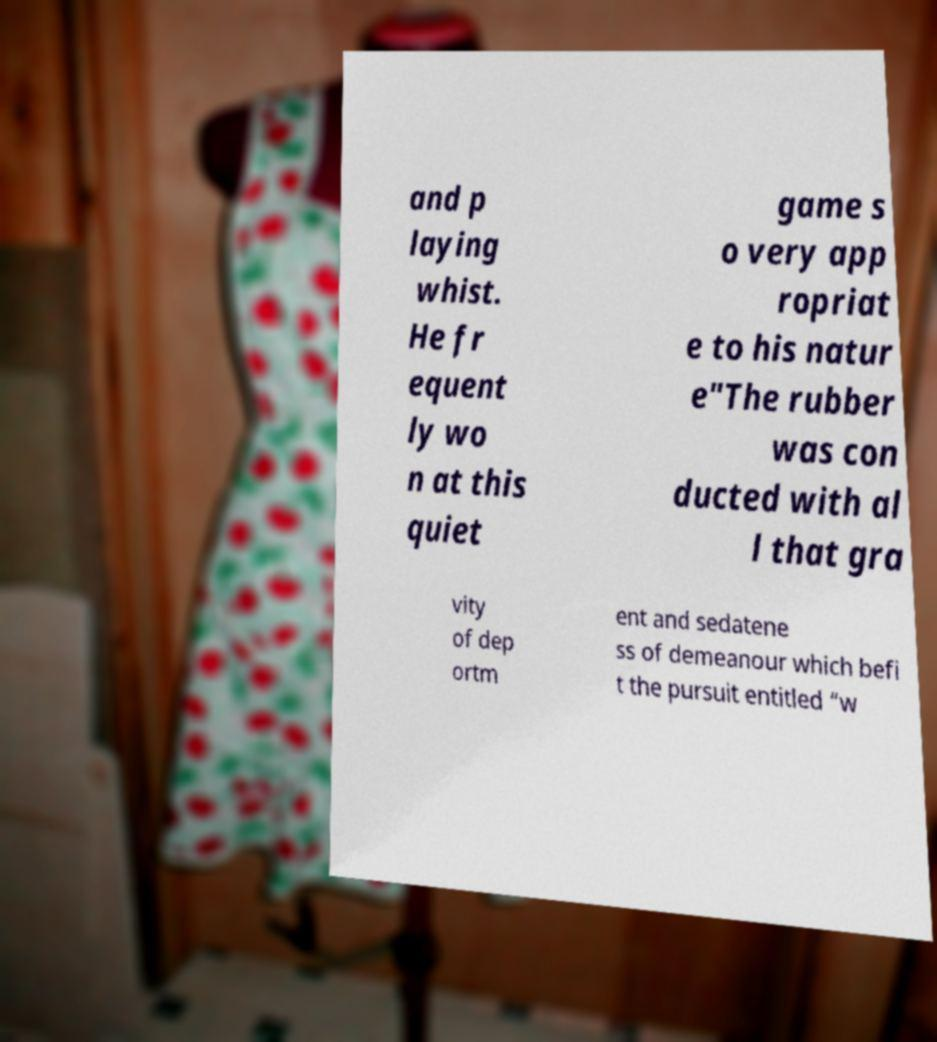Could you extract and type out the text from this image? and p laying whist. He fr equent ly wo n at this quiet game s o very app ropriat e to his natur e"The rubber was con ducted with al l that gra vity of dep ortm ent and sedatene ss of demeanour which befi t the pursuit entitled “w 